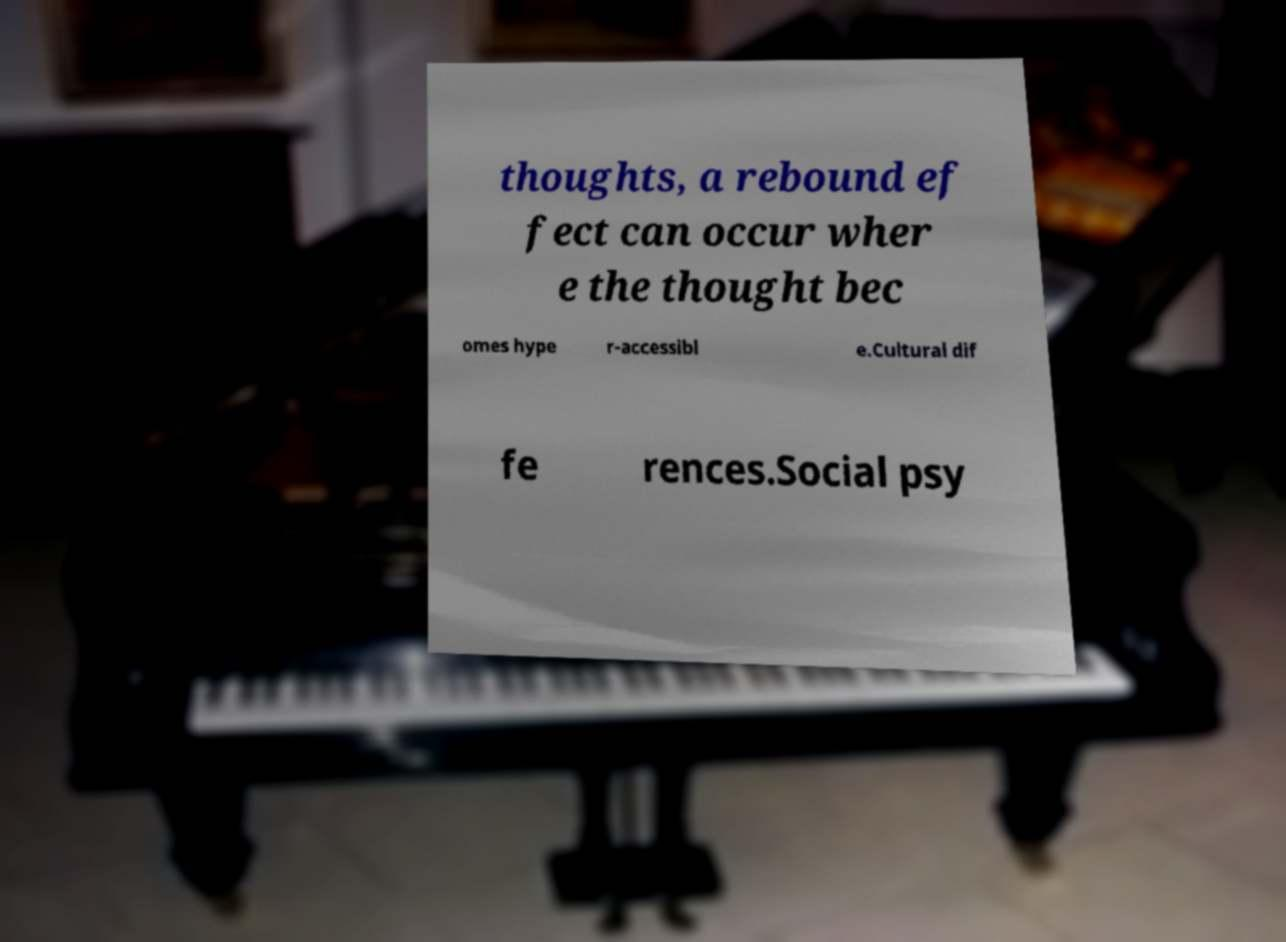Can you read and provide the text displayed in the image?This photo seems to have some interesting text. Can you extract and type it out for me? thoughts, a rebound ef fect can occur wher e the thought bec omes hype r-accessibl e.Cultural dif fe rences.Social psy 